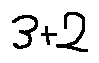Convert formula to latex. <formula><loc_0><loc_0><loc_500><loc_500>3 + 2</formula> 